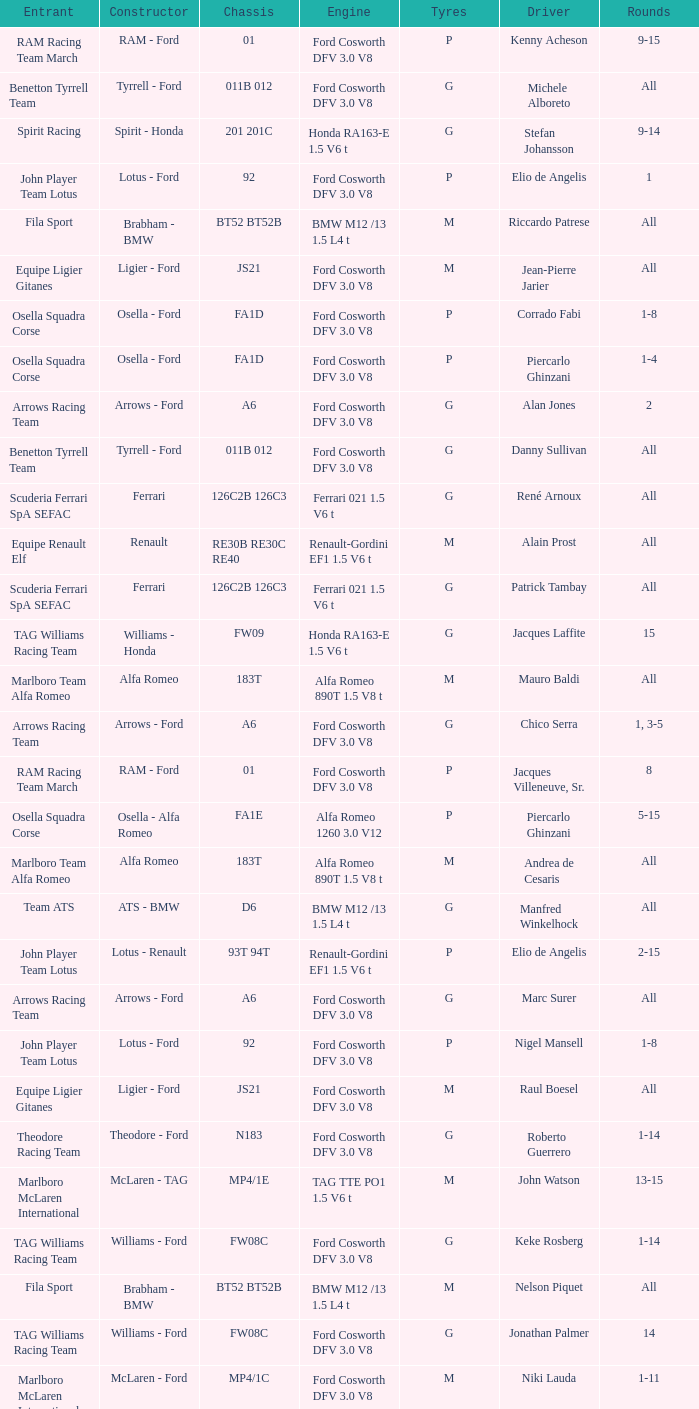Who is the constructor for driver Niki Lauda and a chassis of mp4/1c? McLaren - Ford. 